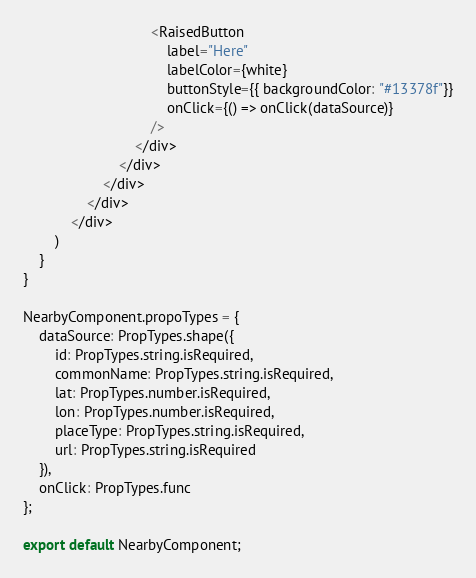Convert code to text. <code><loc_0><loc_0><loc_500><loc_500><_JavaScript_>                                <RaisedButton
                                    label="Here"
                                    labelColor={white}
                                    buttonStyle={{ backgroundColor: "#13378f"}}
                                    onClick={() => onClick(dataSource)}
                                />
                            </div>
                        </div>
                    </div>
                </div>
            </div>
        )
    }
}

NearbyComponent.propoTypes = {
    dataSource: PropTypes.shape({
        id: PropTypes.string.isRequired,
        commonName: PropTypes.string.isRequired,
        lat: PropTypes.number.isRequired,
        lon: PropTypes.number.isRequired,
        placeType: PropTypes.string.isRequired,
        url: PropTypes.string.isRequired
    }),
    onClick: PropTypes.func
};

export default NearbyComponent;</code> 